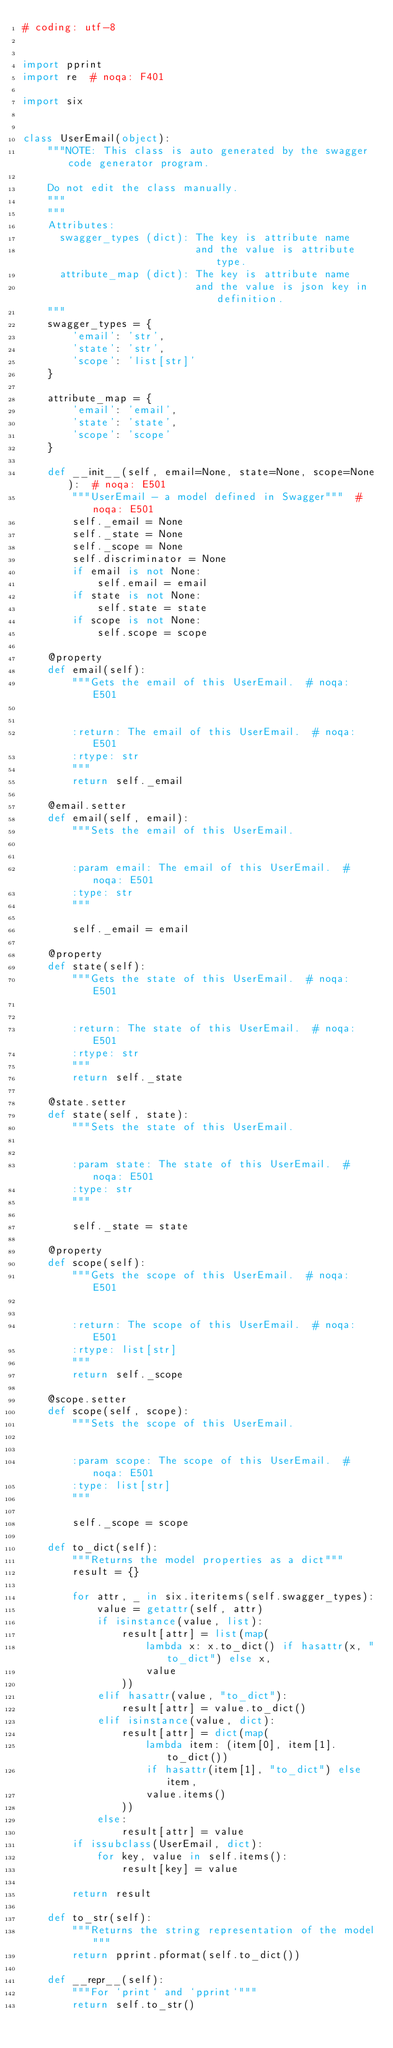Convert code to text. <code><loc_0><loc_0><loc_500><loc_500><_Python_># coding: utf-8


import pprint
import re  # noqa: F401

import six


class UserEmail(object):
    """NOTE: This class is auto generated by the swagger code generator program.

    Do not edit the class manually.
    """
    """
    Attributes:
      swagger_types (dict): The key is attribute name
                            and the value is attribute type.
      attribute_map (dict): The key is attribute name
                            and the value is json key in definition.
    """
    swagger_types = {
        'email': 'str',
        'state': 'str',
        'scope': 'list[str]'
    }

    attribute_map = {
        'email': 'email',
        'state': 'state',
        'scope': 'scope'
    }

    def __init__(self, email=None, state=None, scope=None):  # noqa: E501
        """UserEmail - a model defined in Swagger"""  # noqa: E501
        self._email = None
        self._state = None
        self._scope = None
        self.discriminator = None
        if email is not None:
            self.email = email
        if state is not None:
            self.state = state
        if scope is not None:
            self.scope = scope

    @property
    def email(self):
        """Gets the email of this UserEmail.  # noqa: E501


        :return: The email of this UserEmail.  # noqa: E501
        :rtype: str
        """
        return self._email

    @email.setter
    def email(self, email):
        """Sets the email of this UserEmail.


        :param email: The email of this UserEmail.  # noqa: E501
        :type: str
        """

        self._email = email

    @property
    def state(self):
        """Gets the state of this UserEmail.  # noqa: E501


        :return: The state of this UserEmail.  # noqa: E501
        :rtype: str
        """
        return self._state

    @state.setter
    def state(self, state):
        """Sets the state of this UserEmail.


        :param state: The state of this UserEmail.  # noqa: E501
        :type: str
        """

        self._state = state

    @property
    def scope(self):
        """Gets the scope of this UserEmail.  # noqa: E501


        :return: The scope of this UserEmail.  # noqa: E501
        :rtype: list[str]
        """
        return self._scope

    @scope.setter
    def scope(self, scope):
        """Sets the scope of this UserEmail.


        :param scope: The scope of this UserEmail.  # noqa: E501
        :type: list[str]
        """

        self._scope = scope

    def to_dict(self):
        """Returns the model properties as a dict"""
        result = {}

        for attr, _ in six.iteritems(self.swagger_types):
            value = getattr(self, attr)
            if isinstance(value, list):
                result[attr] = list(map(
                    lambda x: x.to_dict() if hasattr(x, "to_dict") else x,
                    value
                ))
            elif hasattr(value, "to_dict"):
                result[attr] = value.to_dict()
            elif isinstance(value, dict):
                result[attr] = dict(map(
                    lambda item: (item[0], item[1].to_dict())
                    if hasattr(item[1], "to_dict") else item,
                    value.items()
                ))
            else:
                result[attr] = value
        if issubclass(UserEmail, dict):
            for key, value in self.items():
                result[key] = value

        return result

    def to_str(self):
        """Returns the string representation of the model"""
        return pprint.pformat(self.to_dict())

    def __repr__(self):
        """For `print` and `pprint`"""
        return self.to_str()
</code> 